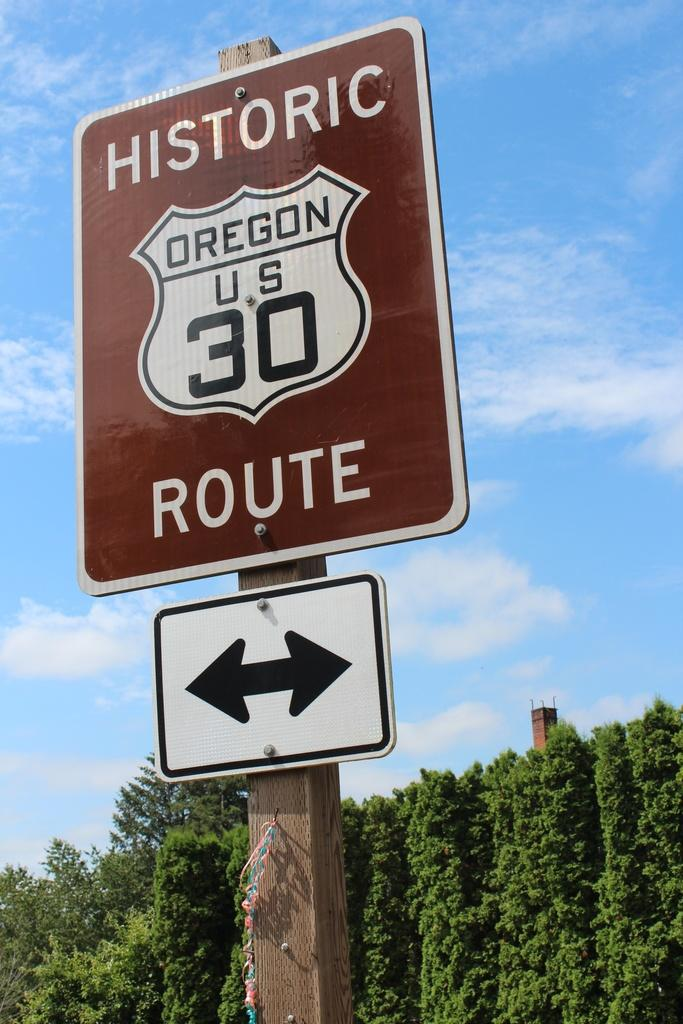<image>
Render a clear and concise summary of the photo. A brown and white sign with historic route us 30 written on it. 